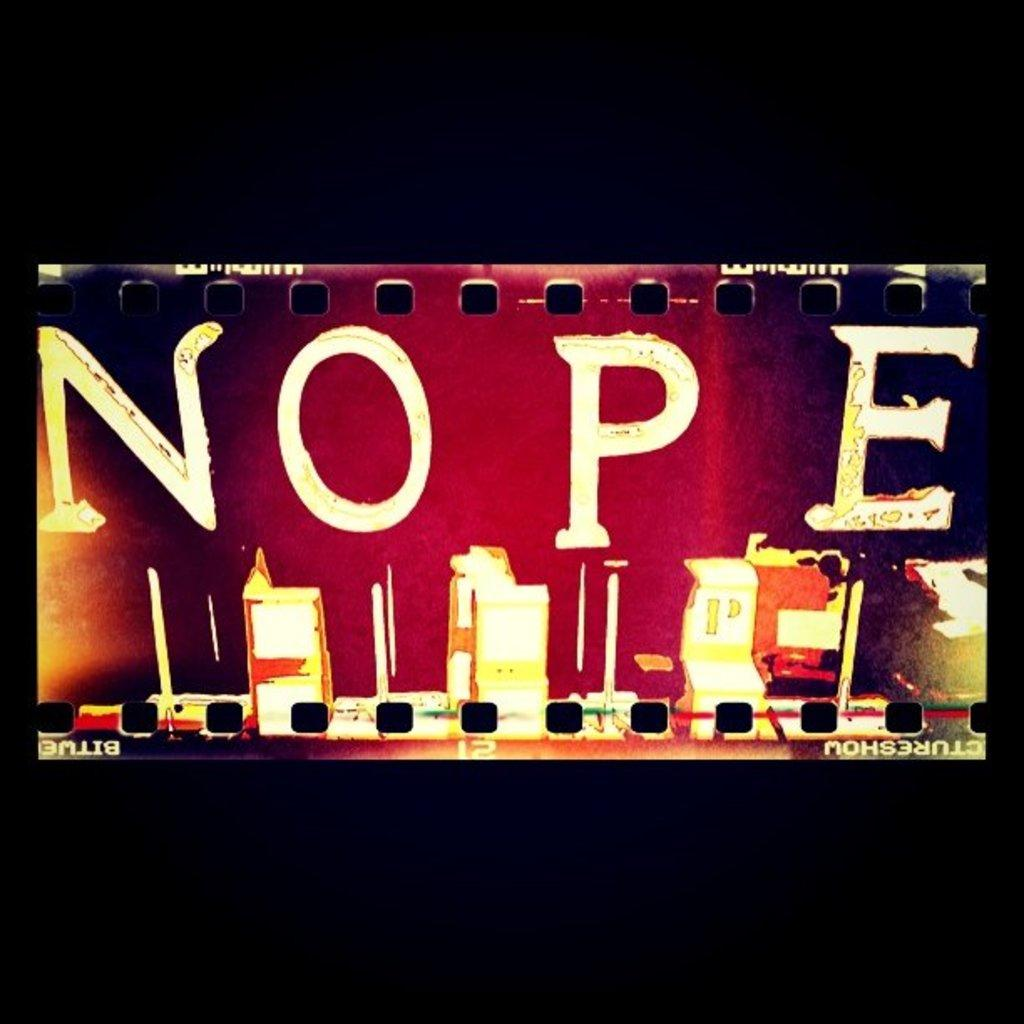<image>
Summarize the visual content of the image. In bold letters the word NOPE is displayed on something that looks like old film. 